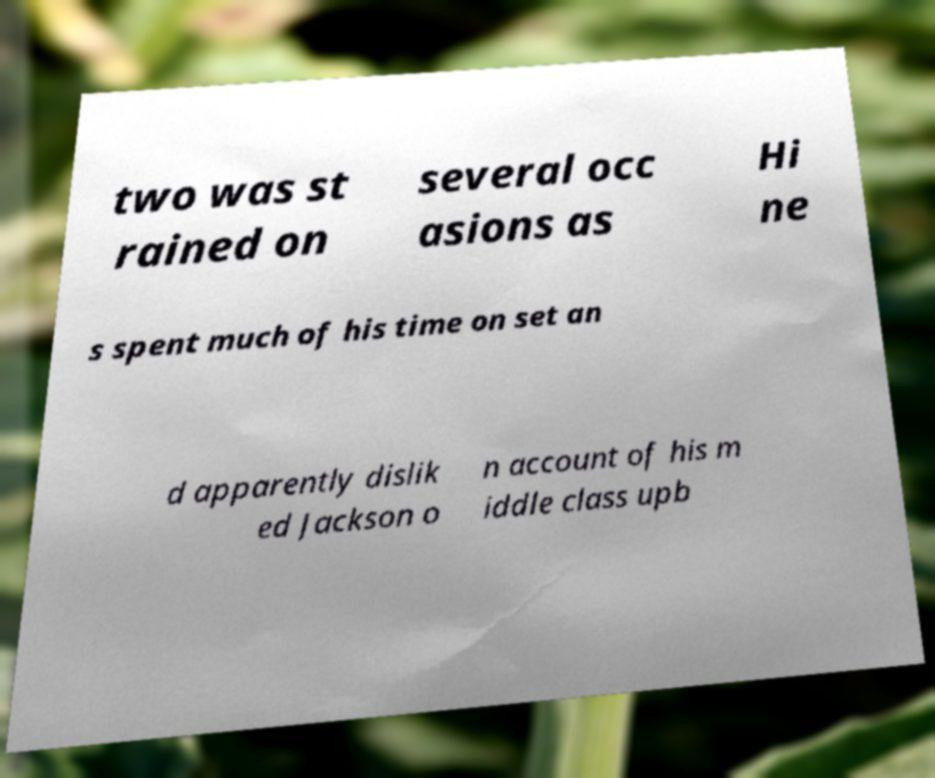Please read and relay the text visible in this image. What does it say? two was st rained on several occ asions as Hi ne s spent much of his time on set an d apparently dislik ed Jackson o n account of his m iddle class upb 